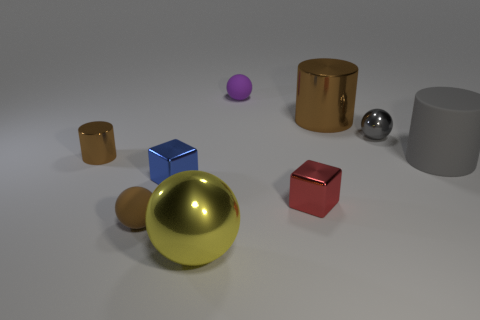Subtract all cylinders. How many objects are left? 6 Subtract 0 green cubes. How many objects are left? 9 Subtract all big brown matte cylinders. Subtract all brown cylinders. How many objects are left? 7 Add 3 brown cylinders. How many brown cylinders are left? 5 Add 5 purple rubber things. How many purple rubber things exist? 6 